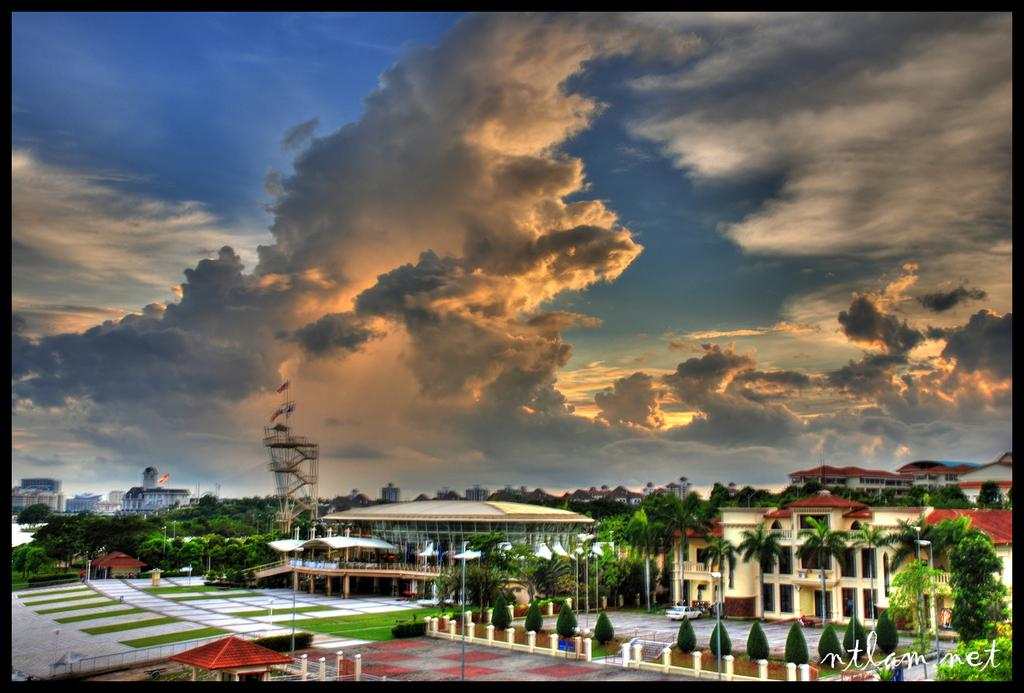What type of structures can be seen in the image? There are buildings and houses in the image. What other natural elements are present in the image? There are trees in the image. What is visible at the top of the image? The sky is visible at the top of the image. What is the weather like in the image? The sky appears to be sunny, suggesting a clear and bright day. What type of care can be seen being provided to the fictional characters in the image? There are no fictional characters present in the image, and therefore no care is being provided. 